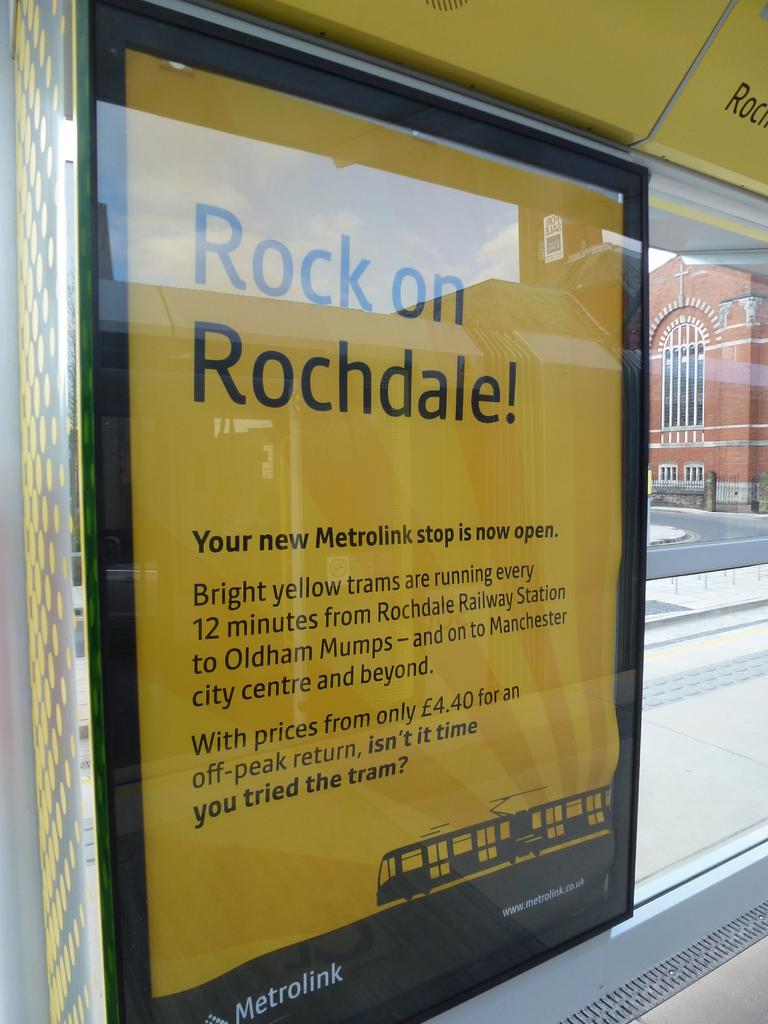<image>
Provide a brief description of the given image. A bus stop advertisement informing riders about a new Metrolink stop 